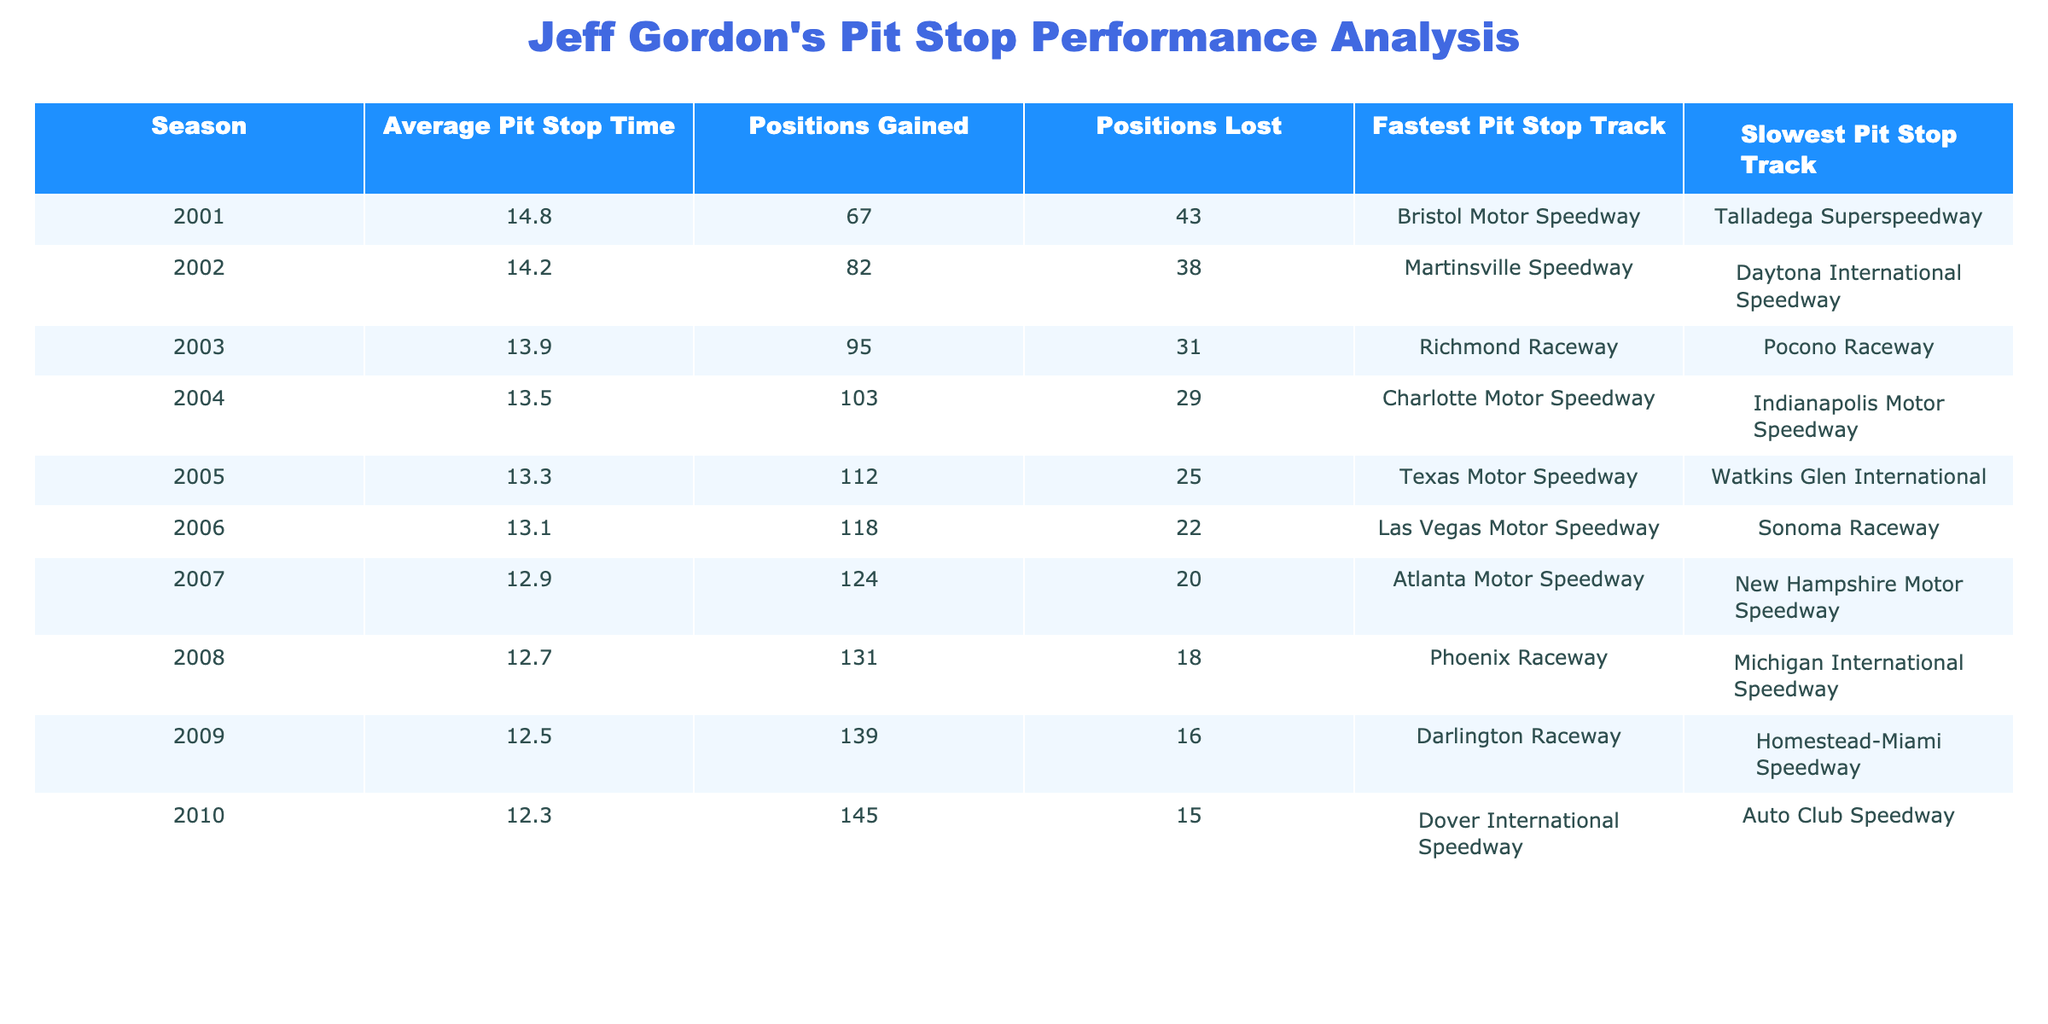What was Jeff Gordon's average pit stop time in 2001? The table shows that the average pit stop time for the 2001 season is listed under the "Average Pit Stop Time" column, which states 14.8 seconds.
Answer: 14.8 seconds In which season did Jeff Gordon gain the most positions? By examining the "Positions Gained" column, the maximum value is 145, which corresponds to the 2010 season.
Answer: 2010 What is the difference in average pit stop time between 2001 and 2005? The average pit stop time for 2001 is 14.8 seconds and for 2005 is 13.3 seconds. The difference is 14.8 - 13.3 = 1.5 seconds.
Answer: 1.5 seconds Which track had the fastest pit stop for Jeff Gordon in 2003? The "Fastest Pit Stop Track" for the 2003 season is listed as Richmond Raceway.
Answer: Richmond Raceway Did Jeff Gordon ever gain more positions than he lost in any season? By checking the "Positions Gained" and "Positions Lost" columns, we find that he gained more positions than he lost in every season listed.
Answer: Yes What was the average positions gained over the years from 2001 to 2010? By summing the "Positions Gained" from each season (67+82+95+103+112+118+124+131+139+145) = 1,066 and dividing by the count of seasons (10), the average is 1,066/10 = 106.6.
Answer: 106.6 In which season did he have his slowest pit stop, and what was the time? The slowest pit stop time is noted in the "Slowest Pit Stop Track" column in the table, which is 14.8 seconds for Talladega Superspeedway in 2001.
Answer: 2001, 14.8 seconds How many positions did Jeff Gordon lose in 2006? The "Positions Lost" column indicates that Jeff Gordon lost 22 positions in the 2006 season.
Answer: 22 positions What trend is observed in Jeff Gordon's pit stop times from 2001 to 2010? Observing the "Average Pit Stop Time" column reveals a decreasing trend in pit stop times from 14.8 seconds in 2001 to 12.3 seconds in 2010.
Answer: Decreasing trend Was there a season where he gained more than 100 positions and also had an average pit stop time below 14 seconds? In analyzing seasons, 2004 has 103 positions gained and an average pit stop time of 13.5 seconds, fitting both criteria.
Answer: Yes 